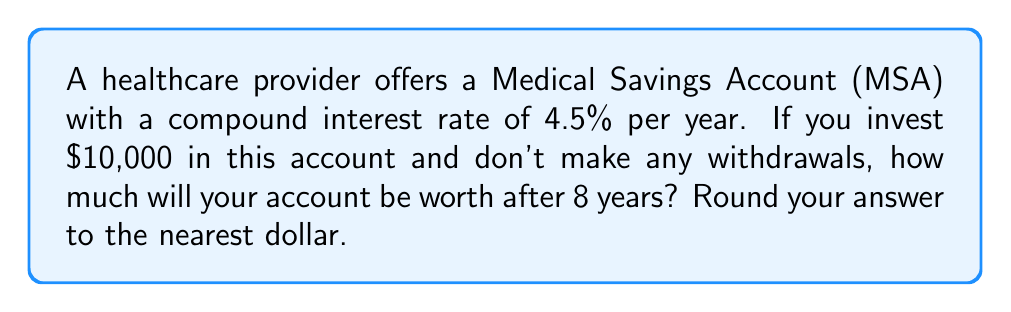Solve this math problem. To solve this problem, we'll use the compound interest formula:

$$A = P(1 + r)^n$$

Where:
$A$ = final amount
$P$ = principal (initial investment)
$r$ = annual interest rate (as a decimal)
$n$ = number of years

Given:
$P = $10,000$
$r = 4.5\% = 0.045$
$n = 8$ years

Let's substitute these values into the formula:

$$A = 10000(1 + 0.045)^8$$

Now, let's calculate step by step:

1) First, add 1 to the interest rate:
   $1 + 0.045 = 1.045$

2) Now, raise this to the 8th power:
   $1.045^8 \approx 1.4185$

3) Multiply this by the principal:
   $10000 \times 1.4185 \approx 14185$

4) Round to the nearest dollar:
   $14185$

Therefore, after 8 years, the account will be worth $14,185.
Answer: $14,185 